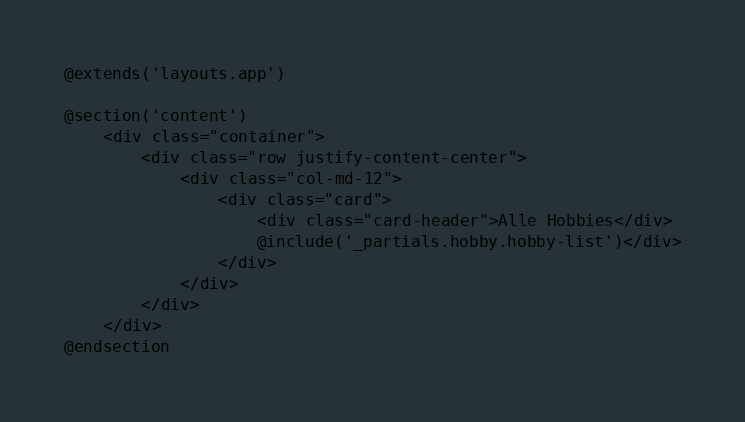<code> <loc_0><loc_0><loc_500><loc_500><_PHP_>@extends('layouts.app')

@section('content')
    <div class="container">
        <div class="row justify-content-center">
            <div class="col-md-12">
                <div class="card">
                    <div class="card-header">Alle Hobbies</div>
                    @include('_partials.hobby.hobby-list')</div>
                </div>
            </div>
        </div>
    </div>
@endsection
</code> 